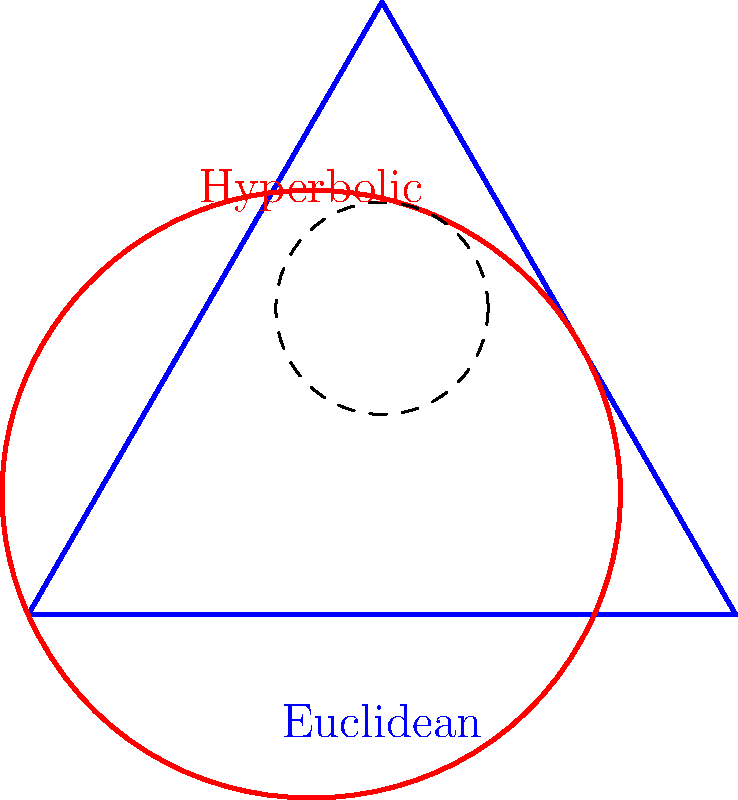In the diagram above, a Euclidean triangle (blue) and a hyperbolic triangle (red) are shown. How does the sum of the interior angles of the hyperbolic triangle compare to that of the Euclidean triangle? To understand the difference between the sum of interior angles in Euclidean and hyperbolic triangles, let's consider the following steps:

1. Euclidean triangle:
   - In Euclidean geometry, the sum of the interior angles of any triangle is always 180°.
   - This is a fundamental property of Euclidean geometry.

2. Hyperbolic triangle:
   - In hyperbolic geometry, the sum of the interior angles of a triangle is always less than 180°.
   - This is due to the negative curvature of hyperbolic space.

3. Angle defect:
   - The difference between 180° and the sum of the angles in a hyperbolic triangle is called the angle defect.
   - The angle defect is directly proportional to the area of the hyperbolic triangle.

4. Comparison:
   - As the sum of angles in a hyperbolic triangle is always less than 180°, it is always less than the sum of angles in a Euclidean triangle.

5. Visualization:
   - In the diagram, the curved sides of the hyperbolic triangle (red) illustrate the negative curvature of hyperbolic space.
   - This curvature causes the angles to be "pulled inward," resulting in a smaller sum compared to the Euclidean triangle.

Therefore, the sum of the interior angles of the hyperbolic triangle is always less than that of the Euclidean triangle.
Answer: Less than 